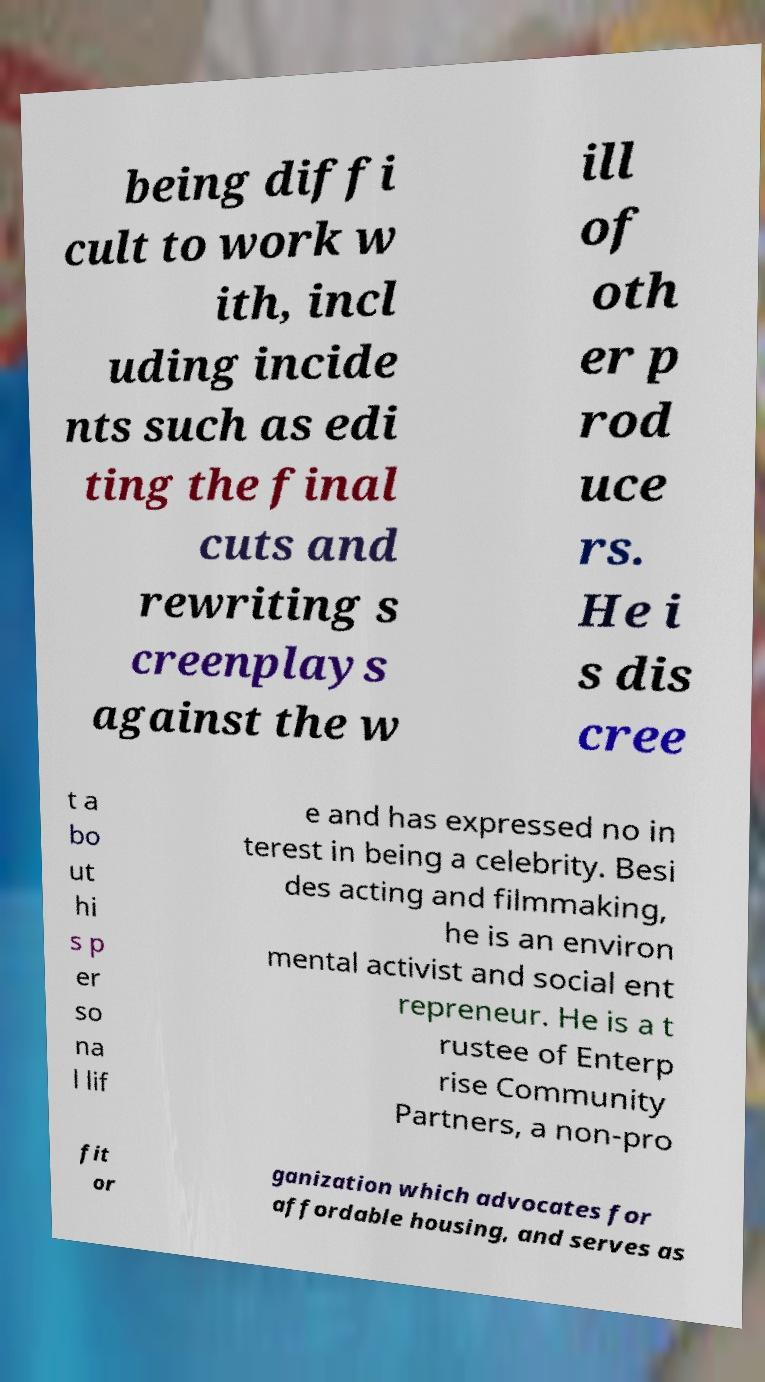I need the written content from this picture converted into text. Can you do that? being diffi cult to work w ith, incl uding incide nts such as edi ting the final cuts and rewriting s creenplays against the w ill of oth er p rod uce rs. He i s dis cree t a bo ut hi s p er so na l lif e and has expressed no in terest in being a celebrity. Besi des acting and filmmaking, he is an environ mental activist and social ent repreneur. He is a t rustee of Enterp rise Community Partners, a non-pro fit or ganization which advocates for affordable housing, and serves as 